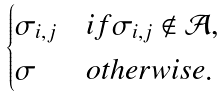<formula> <loc_0><loc_0><loc_500><loc_500>\begin{cases} \sigma _ { i , j } & i f \sigma _ { i , j } \notin \mathcal { A } , \\ \sigma & o t h e r w i s e . \\ \end{cases}</formula> 